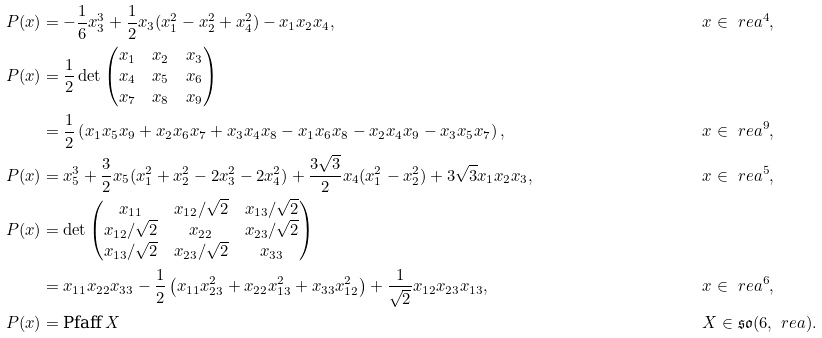<formula> <loc_0><loc_0><loc_500><loc_500>P ( x ) & = - \frac { 1 } { 6 } x _ { 3 } ^ { 3 } + \frac { 1 } { 2 } x _ { 3 } ( x _ { 1 } ^ { 2 } - x _ { 2 } ^ { 2 } + x _ { 4 } ^ { 2 } ) - x _ { 1 } x _ { 2 } x _ { 4 } , & & x \in \ r e a ^ { 4 } , \\ P ( x ) & = \frac { 1 } { 2 } \det \begin{pmatrix} x _ { 1 } & x _ { 2 } & x _ { 3 } \\ x _ { 4 } & x _ { 5 } & x _ { 6 } \\ x _ { 7 } & x _ { 8 } & x _ { 9 } \end{pmatrix} \\ & = \frac { 1 } { 2 } \left ( x _ { 1 } x _ { 5 } x _ { 9 } + x _ { 2 } x _ { 6 } x _ { 7 } + x _ { 3 } x _ { 4 } x _ { 8 } - x _ { 1 } x _ { 6 } x _ { 8 } - x _ { 2 } x _ { 4 } x _ { 9 } - x _ { 3 } x _ { 5 } x _ { 7 } \right ) , & & x \in \ r e a ^ { 9 } , \\ P ( x ) & = x _ { 5 } ^ { 3 } + \frac { 3 } { 2 } x _ { 5 } ( x _ { 1 } ^ { 2 } + x _ { 2 } ^ { 2 } - 2 x _ { 3 } ^ { 2 } - 2 x _ { 4 } ^ { 2 } ) + \frac { 3 \sqrt { 3 } } { 2 } x _ { 4 } ( x _ { 1 } ^ { 2 } - x _ { 2 } ^ { 2 } ) + 3 \sqrt { 3 } x _ { 1 } x _ { 2 } x _ { 3 } , & & x \in \ r e a ^ { 5 } , \\ P ( x ) & = \det \begin{pmatrix} x _ { 1 1 } & x _ { 1 2 } / \sqrt { 2 } & x _ { 1 3 } / \sqrt { 2 } \\ x _ { 1 2 } / \sqrt { 2 } & x _ { 2 2 } & x _ { 2 3 } / \sqrt { 2 } \\ x _ { 1 3 } / \sqrt { 2 } & x _ { 2 3 } / \sqrt { 2 } & x _ { 3 3 } \end{pmatrix} \\ & = x _ { 1 1 } x _ { 2 2 } x _ { 3 3 } - \frac { 1 } { 2 } \left ( x _ { 1 1 } x _ { 2 3 } ^ { 2 } + x _ { 2 2 } x _ { 1 3 } ^ { 2 } + x _ { 3 3 } x _ { 1 2 } ^ { 2 } \right ) + \frac { 1 } { \sqrt { 2 } } x _ { 1 2 } x _ { 2 3 } x _ { 1 3 } , & & x \in \ r e a ^ { 6 } , \\ P ( x ) & = \text {Pfaff} \, X & & X \in \mathfrak { s o } ( 6 , \ r e a ) .</formula> 